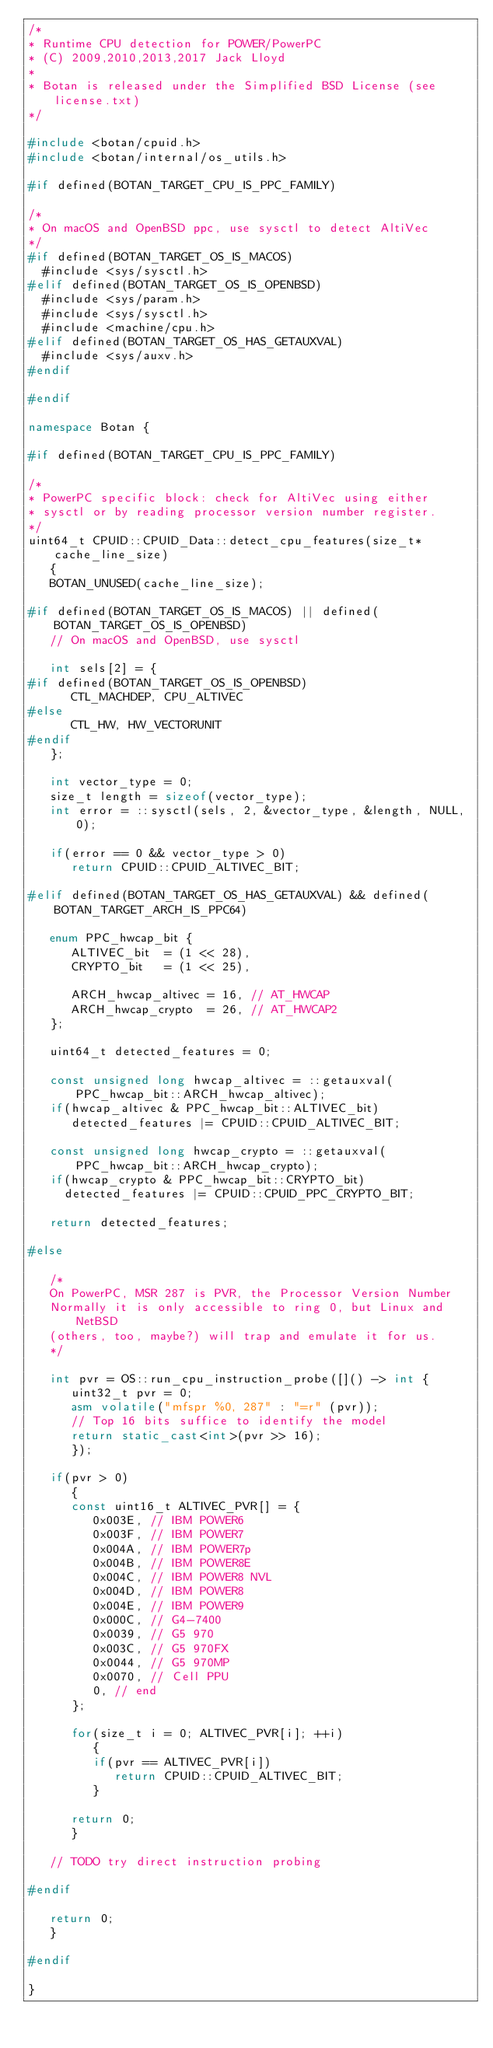Convert code to text. <code><loc_0><loc_0><loc_500><loc_500><_C++_>/*
* Runtime CPU detection for POWER/PowerPC
* (C) 2009,2010,2013,2017 Jack Lloyd
*
* Botan is released under the Simplified BSD License (see license.txt)
*/

#include <botan/cpuid.h>
#include <botan/internal/os_utils.h>

#if defined(BOTAN_TARGET_CPU_IS_PPC_FAMILY)

/*
* On macOS and OpenBSD ppc, use sysctl to detect AltiVec
*/
#if defined(BOTAN_TARGET_OS_IS_MACOS)
  #include <sys/sysctl.h>
#elif defined(BOTAN_TARGET_OS_IS_OPENBSD)
  #include <sys/param.h>
  #include <sys/sysctl.h>
  #include <machine/cpu.h>
#elif defined(BOTAN_TARGET_OS_HAS_GETAUXVAL)
  #include <sys/auxv.h>
#endif

#endif

namespace Botan {

#if defined(BOTAN_TARGET_CPU_IS_PPC_FAMILY)

/*
* PowerPC specific block: check for AltiVec using either
* sysctl or by reading processor version number register.
*/
uint64_t CPUID::CPUID_Data::detect_cpu_features(size_t* cache_line_size)
   {
   BOTAN_UNUSED(cache_line_size);

#if defined(BOTAN_TARGET_OS_IS_MACOS) || defined(BOTAN_TARGET_OS_IS_OPENBSD)
   // On macOS and OpenBSD, use sysctl

   int sels[2] = {
#if defined(BOTAN_TARGET_OS_IS_OPENBSD)
      CTL_MACHDEP, CPU_ALTIVEC
#else
      CTL_HW, HW_VECTORUNIT
#endif
   };

   int vector_type = 0;
   size_t length = sizeof(vector_type);
   int error = ::sysctl(sels, 2, &vector_type, &length, NULL, 0);

   if(error == 0 && vector_type > 0)
      return CPUID::CPUID_ALTIVEC_BIT;

#elif defined(BOTAN_TARGET_OS_HAS_GETAUXVAL) && defined(BOTAN_TARGET_ARCH_IS_PPC64)

   enum PPC_hwcap_bit {
      ALTIVEC_bit  = (1 << 28),
      CRYPTO_bit   = (1 << 25),

      ARCH_hwcap_altivec = 16, // AT_HWCAP
      ARCH_hwcap_crypto  = 26, // AT_HWCAP2
   };

   uint64_t detected_features = 0;

   const unsigned long hwcap_altivec = ::getauxval(PPC_hwcap_bit::ARCH_hwcap_altivec);
   if(hwcap_altivec & PPC_hwcap_bit::ALTIVEC_bit)
      detected_features |= CPUID::CPUID_ALTIVEC_BIT;

   const unsigned long hwcap_crypto = ::getauxval(PPC_hwcap_bit::ARCH_hwcap_crypto);
   if(hwcap_crypto & PPC_hwcap_bit::CRYPTO_bit)
     detected_features |= CPUID::CPUID_PPC_CRYPTO_BIT;

   return detected_features;

#else

   /*
   On PowerPC, MSR 287 is PVR, the Processor Version Number
   Normally it is only accessible to ring 0, but Linux and NetBSD
   (others, too, maybe?) will trap and emulate it for us.
   */

   int pvr = OS::run_cpu_instruction_probe([]() -> int {
      uint32_t pvr = 0;
      asm volatile("mfspr %0, 287" : "=r" (pvr));
      // Top 16 bits suffice to identify the model
      return static_cast<int>(pvr >> 16);
      });

   if(pvr > 0)
      {
      const uint16_t ALTIVEC_PVR[] = {
         0x003E, // IBM POWER6
         0x003F, // IBM POWER7
         0x004A, // IBM POWER7p
         0x004B, // IBM POWER8E
         0x004C, // IBM POWER8 NVL
         0x004D, // IBM POWER8
         0x004E, // IBM POWER9
         0x000C, // G4-7400
         0x0039, // G5 970
         0x003C, // G5 970FX
         0x0044, // G5 970MP
         0x0070, // Cell PPU
         0, // end
      };

      for(size_t i = 0; ALTIVEC_PVR[i]; ++i)
         {
         if(pvr == ALTIVEC_PVR[i])
            return CPUID::CPUID_ALTIVEC_BIT;
         }

      return 0;
      }

   // TODO try direct instruction probing

#endif

   return 0;
   }

#endif

}
</code> 